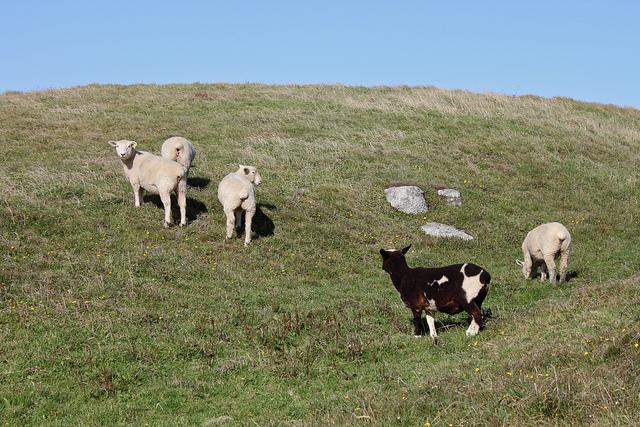Are all the sheep the same color?
Write a very short answer. No. How many sheep are eating?
Quick response, please. 2. How many white animals do you see?
Keep it brief. 4. What color are the animals?
Be succinct. White and black. How many animals are shown?
Answer briefly. 5. 